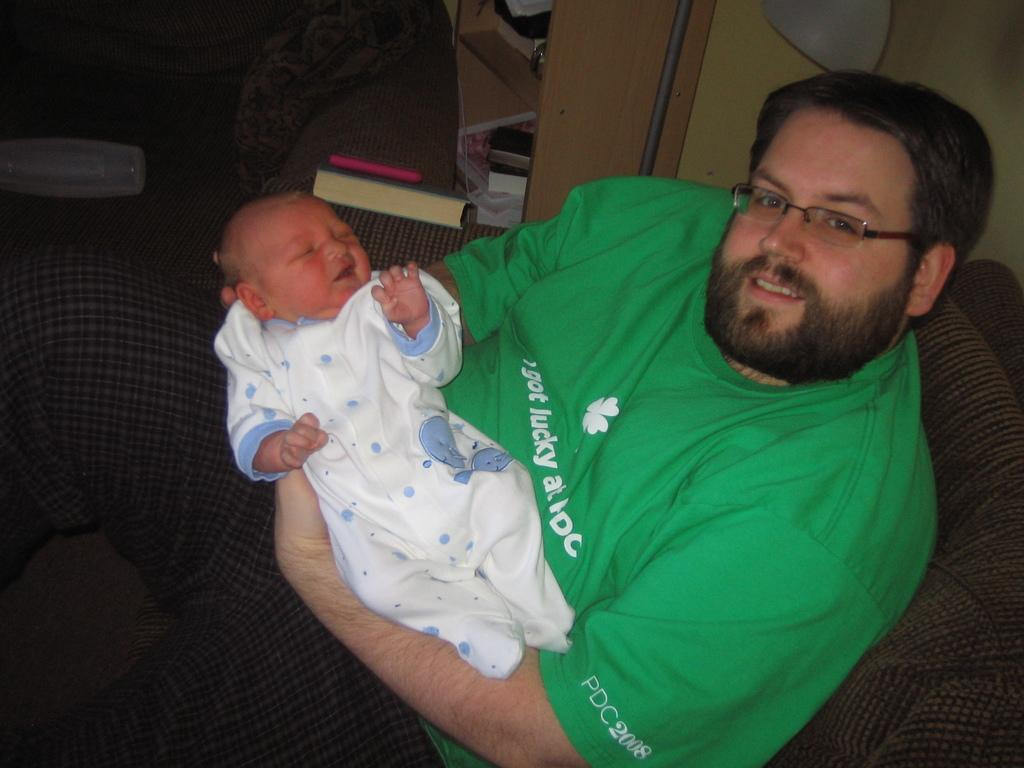<image>
Provide a brief description of the given image. a man with a baby and the word lucky on his shirt 